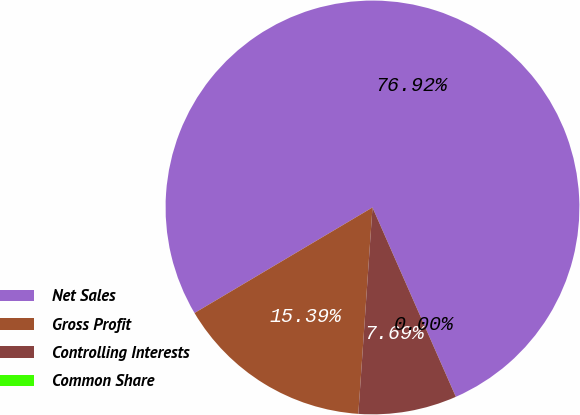<chart> <loc_0><loc_0><loc_500><loc_500><pie_chart><fcel>Net Sales<fcel>Gross Profit<fcel>Controlling Interests<fcel>Common Share<nl><fcel>76.92%<fcel>15.39%<fcel>7.69%<fcel>0.0%<nl></chart> 